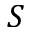<formula> <loc_0><loc_0><loc_500><loc_500>S</formula> 